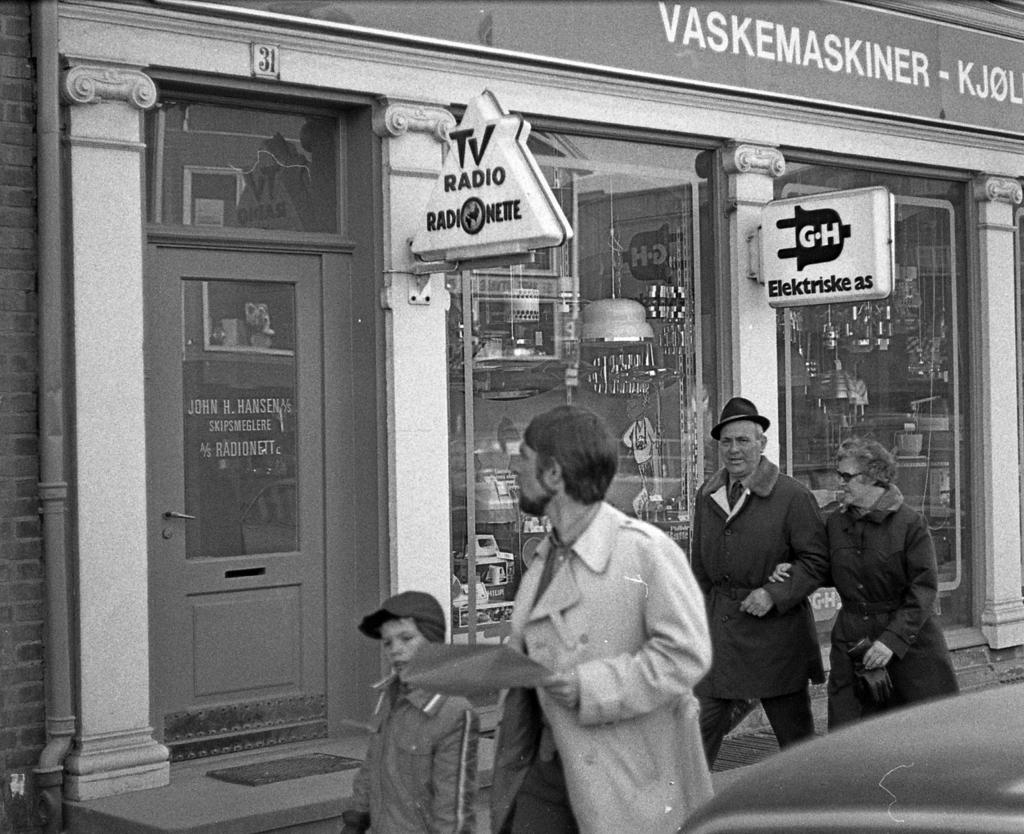What are the people in the image doing? The people in the image are walking in the center of the image. What can be seen in the background of the image? There is a building and boards visible in the background of the image. Are there any objects or structures present in the image? Yes, there are pipes present in the image. What type of list can be seen being carried by the people in the image? There is no list visible in the image; the people are simply walking. 